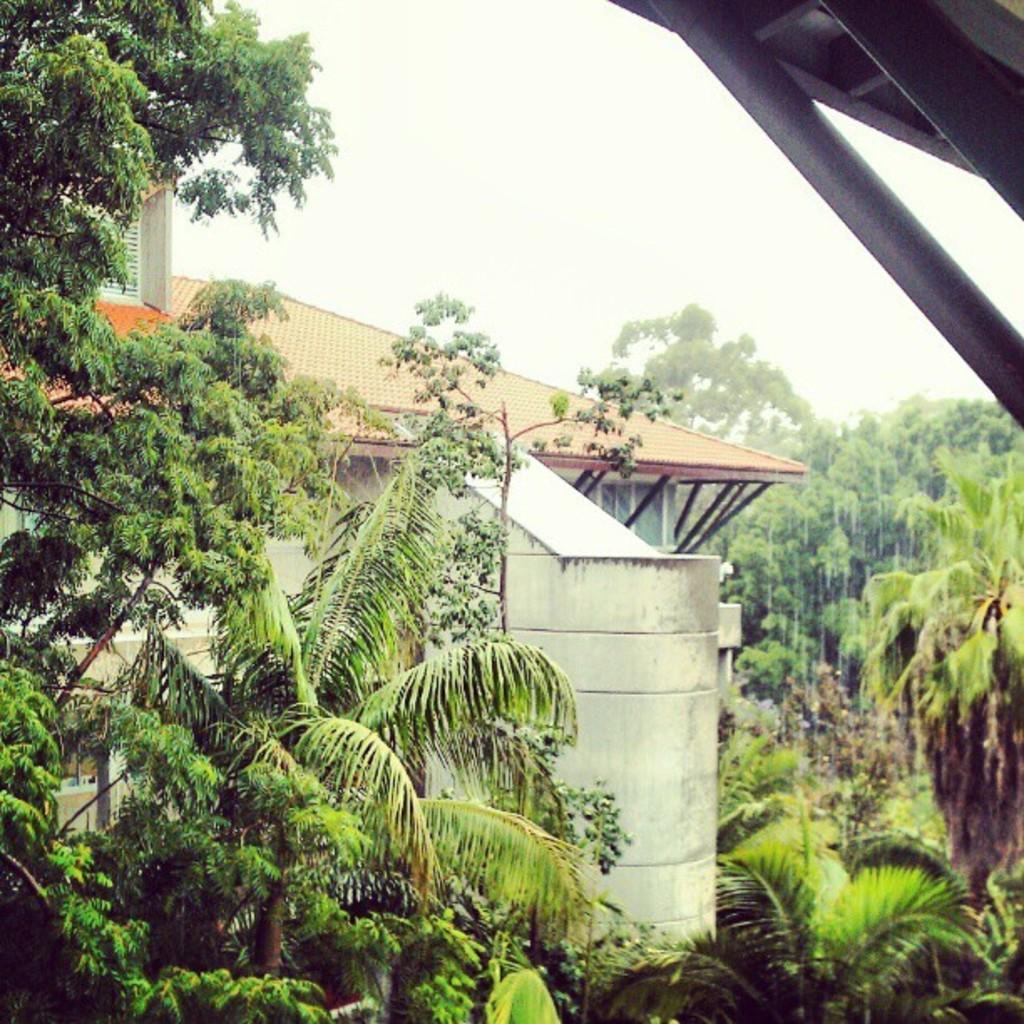How would you summarize this image in a sentence or two? In this image we can see trees, plants, grass, building and sky. 